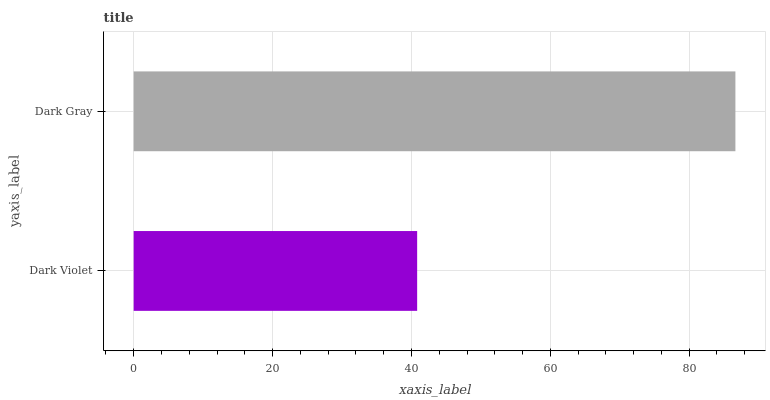Is Dark Violet the minimum?
Answer yes or no. Yes. Is Dark Gray the maximum?
Answer yes or no. Yes. Is Dark Gray the minimum?
Answer yes or no. No. Is Dark Gray greater than Dark Violet?
Answer yes or no. Yes. Is Dark Violet less than Dark Gray?
Answer yes or no. Yes. Is Dark Violet greater than Dark Gray?
Answer yes or no. No. Is Dark Gray less than Dark Violet?
Answer yes or no. No. Is Dark Gray the high median?
Answer yes or no. Yes. Is Dark Violet the low median?
Answer yes or no. Yes. Is Dark Violet the high median?
Answer yes or no. No. Is Dark Gray the low median?
Answer yes or no. No. 